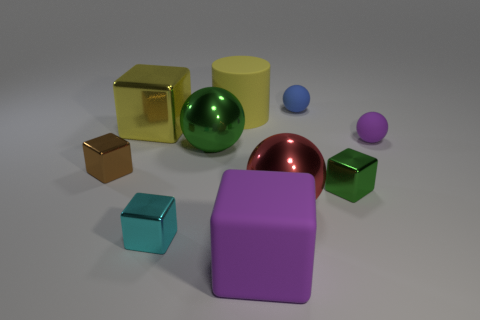Subtract all cyan cubes. How many cubes are left? 4 Subtract all blue spheres. How many spheres are left? 3 Subtract all green blocks. Subtract all purple spheres. How many blocks are left? 4 Subtract all red cylinders. How many green blocks are left? 1 Add 3 purple matte blocks. How many purple matte blocks exist? 4 Subtract 1 purple blocks. How many objects are left? 9 Subtract all balls. How many objects are left? 6 Subtract 1 balls. How many balls are left? 3 Subtract all tiny brown metallic objects. Subtract all metallic objects. How many objects are left? 3 Add 5 large yellow metal cubes. How many large yellow metal cubes are left? 6 